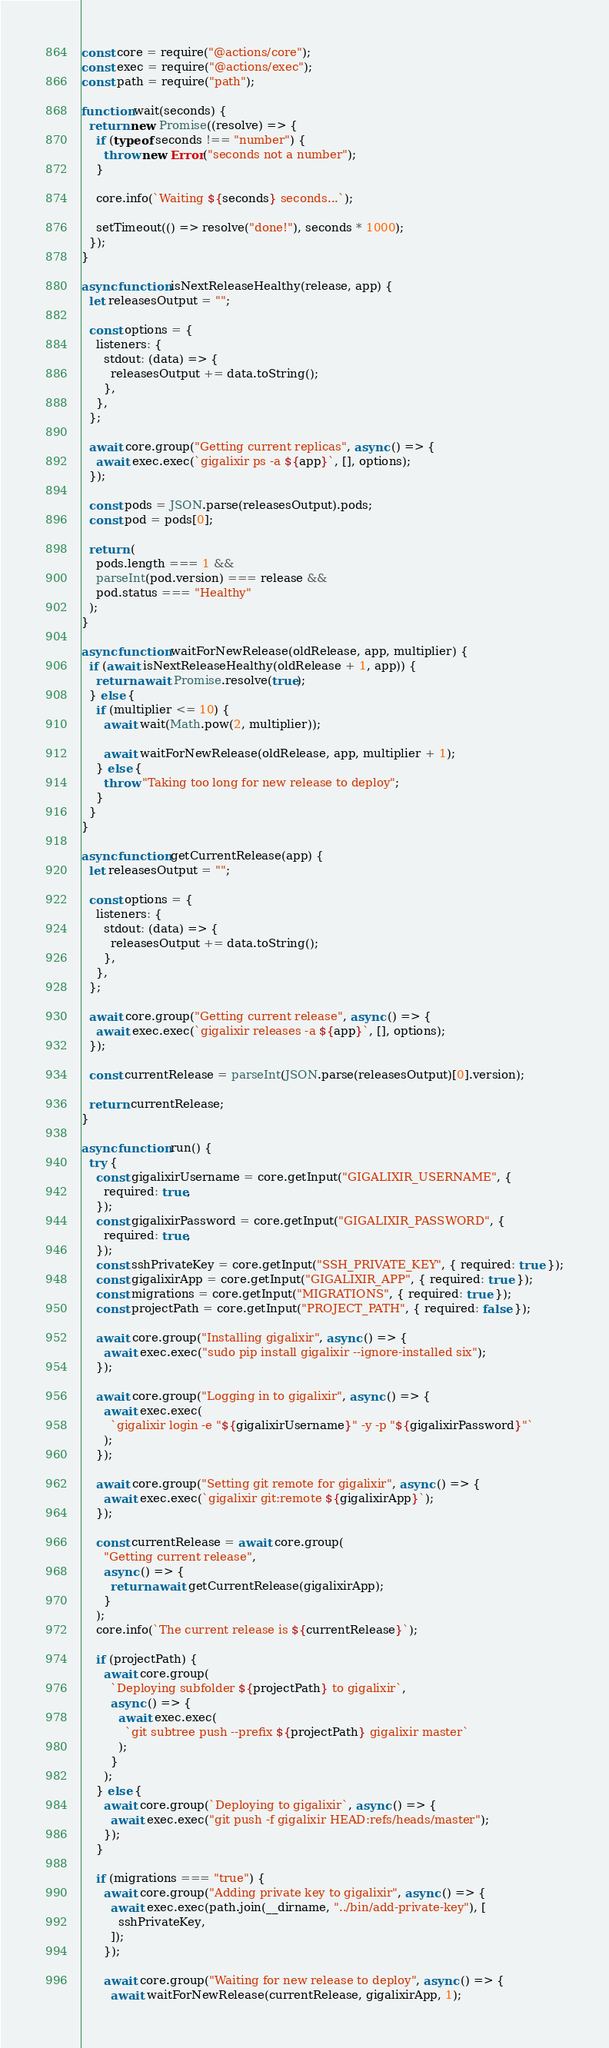<code> <loc_0><loc_0><loc_500><loc_500><_JavaScript_>const core = require("@actions/core");
const exec = require("@actions/exec");
const path = require("path");

function wait(seconds) {
  return new Promise((resolve) => {
    if (typeof seconds !== "number") {
      throw new Error("seconds not a number");
    }

    core.info(`Waiting ${seconds} seconds...`);

    setTimeout(() => resolve("done!"), seconds * 1000);
  });
}

async function isNextReleaseHealthy(release, app) {
  let releasesOutput = "";

  const options = {
    listeners: {
      stdout: (data) => {
        releasesOutput += data.toString();
      },
    },
  };

  await core.group("Getting current replicas", async () => {
    await exec.exec(`gigalixir ps -a ${app}`, [], options);
  });

  const pods = JSON.parse(releasesOutput).pods;
  const pod = pods[0];

  return (
    pods.length === 1 &&
    parseInt(pod.version) === release &&
    pod.status === "Healthy"
  );
}

async function waitForNewRelease(oldRelease, app, multiplier) {
  if (await isNextReleaseHealthy(oldRelease + 1, app)) {
    return await Promise.resolve(true);
  } else {
    if (multiplier <= 10) {
      await wait(Math.pow(2, multiplier));

      await waitForNewRelease(oldRelease, app, multiplier + 1);
    } else {
      throw "Taking too long for new release to deploy";
    }
  }
}

async function getCurrentRelease(app) {
  let releasesOutput = "";

  const options = {
    listeners: {
      stdout: (data) => {
        releasesOutput += data.toString();
      },
    },
  };

  await core.group("Getting current release", async () => {
    await exec.exec(`gigalixir releases -a ${app}`, [], options);
  });

  const currentRelease = parseInt(JSON.parse(releasesOutput)[0].version);

  return currentRelease;
}

async function run() {
  try {
    const gigalixirUsername = core.getInput("GIGALIXIR_USERNAME", {
      required: true,
    });
    const gigalixirPassword = core.getInput("GIGALIXIR_PASSWORD", {
      required: true,
    });
    const sshPrivateKey = core.getInput("SSH_PRIVATE_KEY", { required: true });
    const gigalixirApp = core.getInput("GIGALIXIR_APP", { required: true });
    const migrations = core.getInput("MIGRATIONS", { required: true });
    const projectPath = core.getInput("PROJECT_PATH", { required: false });

    await core.group("Installing gigalixir", async () => {
      await exec.exec("sudo pip install gigalixir --ignore-installed six");
    });

    await core.group("Logging in to gigalixir", async () => {
      await exec.exec(
        `gigalixir login -e "${gigalixirUsername}" -y -p "${gigalixirPassword}"`
      );
    });

    await core.group("Setting git remote for gigalixir", async () => {
      await exec.exec(`gigalixir git:remote ${gigalixirApp}`);
    });

    const currentRelease = await core.group(
      "Getting current release",
      async () => {
        return await getCurrentRelease(gigalixirApp);
      }
    );
    core.info(`The current release is ${currentRelease}`);

    if (projectPath) {
      await core.group(
        `Deploying subfolder ${projectPath} to gigalixir`,
        async () => {
          await exec.exec(
            `git subtree push --prefix ${projectPath} gigalixir master`
          );
        }
      );
    } else {
      await core.group(`Deploying to gigalixir`, async () => {
        await exec.exec("git push -f gigalixir HEAD:refs/heads/master");
      });
    }

    if (migrations === "true") {
      await core.group("Adding private key to gigalixir", async () => {
        await exec.exec(path.join(__dirname, "../bin/add-private-key"), [
          sshPrivateKey,
        ]);
      });

      await core.group("Waiting for new release to deploy", async () => {
        await waitForNewRelease(currentRelease, gigalixirApp, 1);</code> 